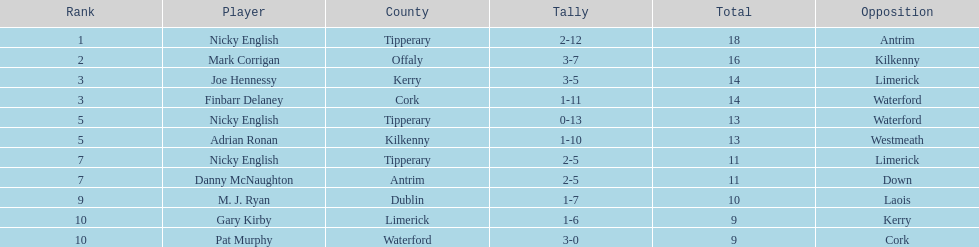Who held a higher rank than mark corrigan? Nicky English. 